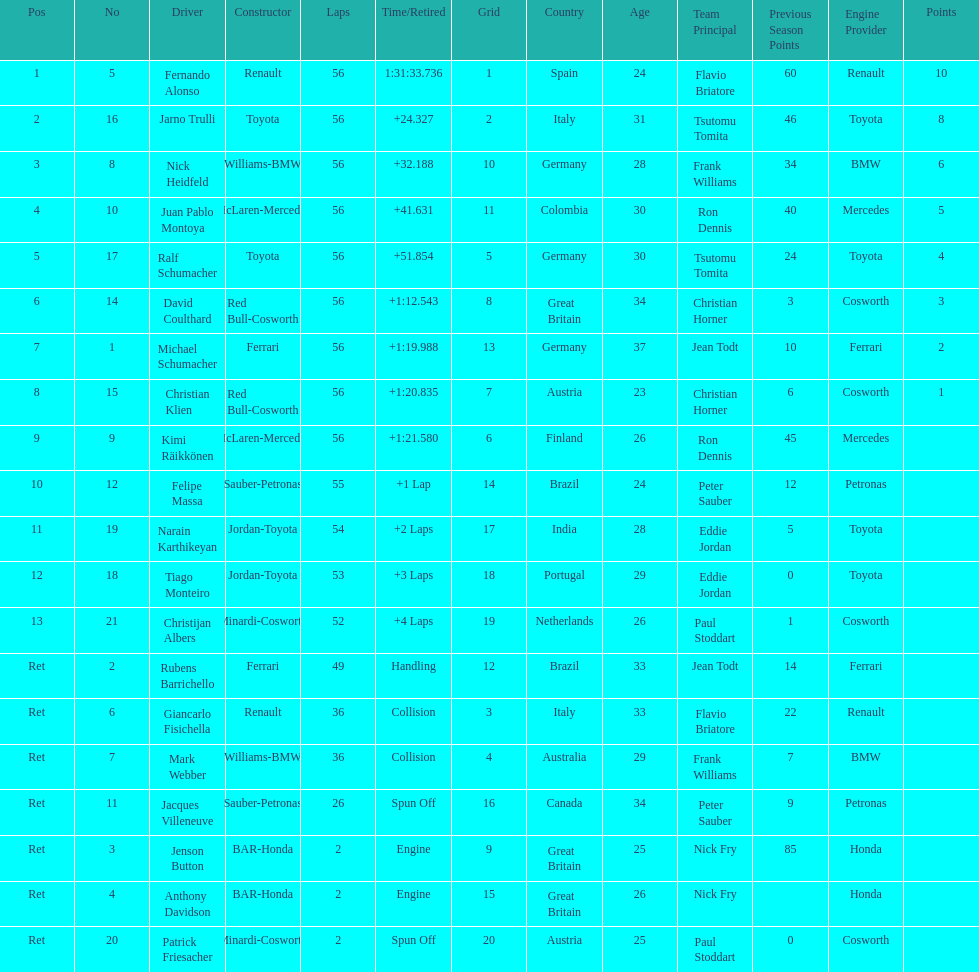Who was the last driver to actually finish the race? Christijan Albers. 